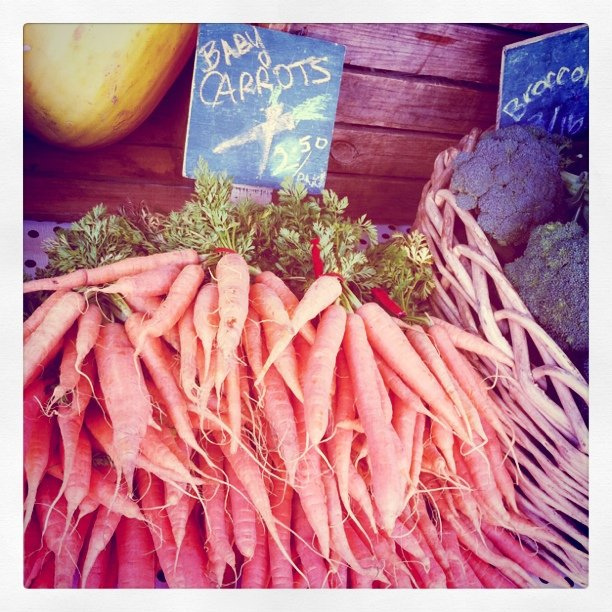Are those carrots organic? Without any visible certification or labeling in the image, it is not possible to confirm whether the carrots are organic. 